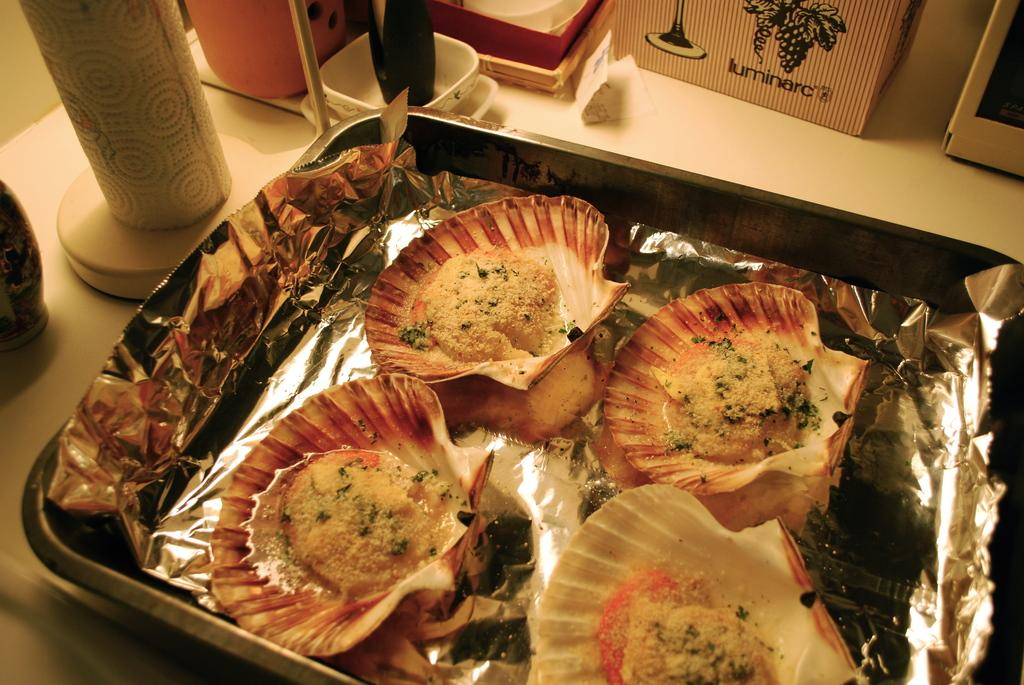What type of furniture is present in the image? There is a table in the image. What objects are placed on the table? There are bowls and boxes on the table. Is there any other item on the table besides the bowls and boxes? Yes, there is a tray on the table. What type of business is being conducted at the table in the image? There is no indication of any business being conducted in the image; it only shows a table with bowls, boxes, and a tray. 